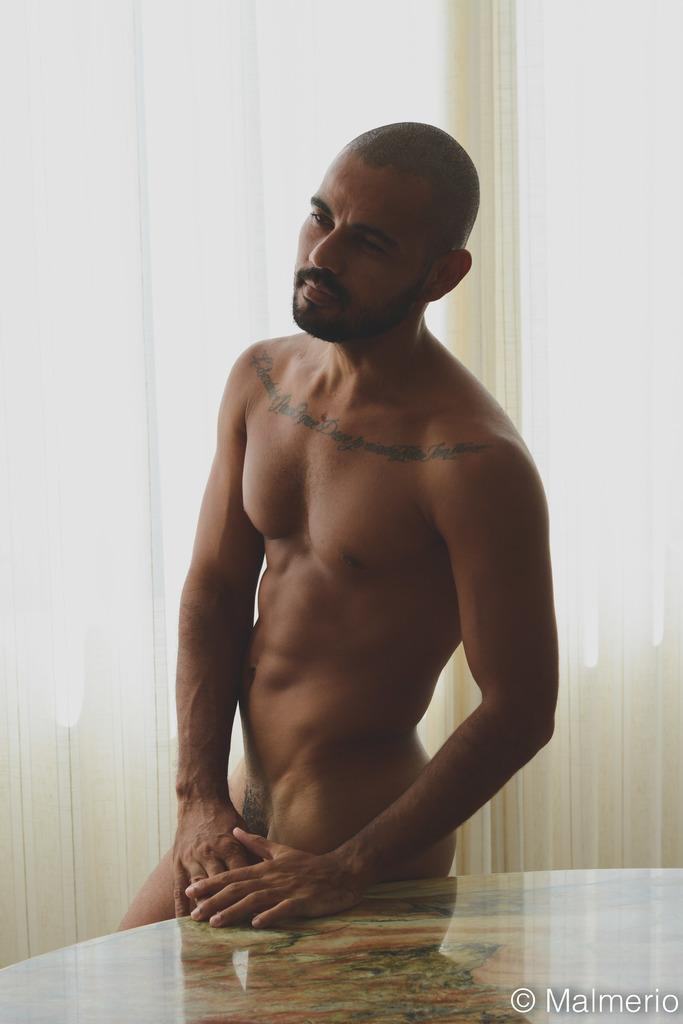What is the main subject of the image? There is a man in the image. Can you describe the man's appearance? The man is naked in the image. What other objects or features can be seen in the image? There is a table in the image. Is there any text or marking on the image? Yes, there is a watermark in the image. What is the color of the background in the image? The background of the image is white. What type of clouds can be seen in the image? There are no clouds visible in the image, as the background is white. How does the man express regret in the image? There is no indication of regret in the image, as it only shows a naked man and a table. 